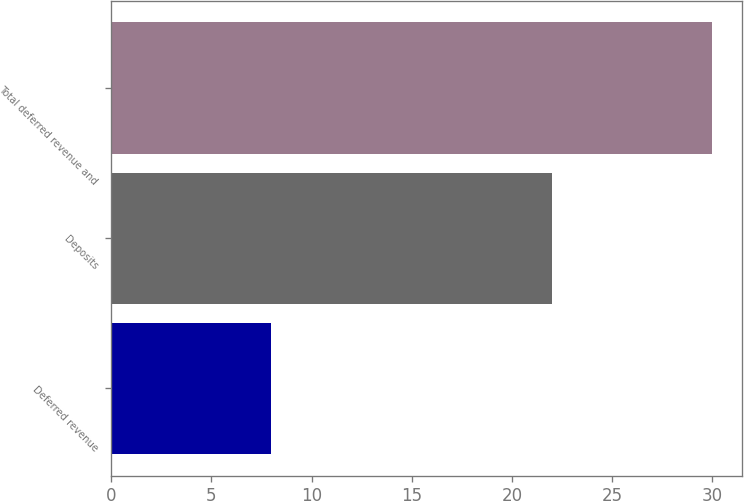<chart> <loc_0><loc_0><loc_500><loc_500><bar_chart><fcel>Deferred revenue<fcel>Deposits<fcel>Total deferred revenue and<nl><fcel>8<fcel>22<fcel>30<nl></chart> 